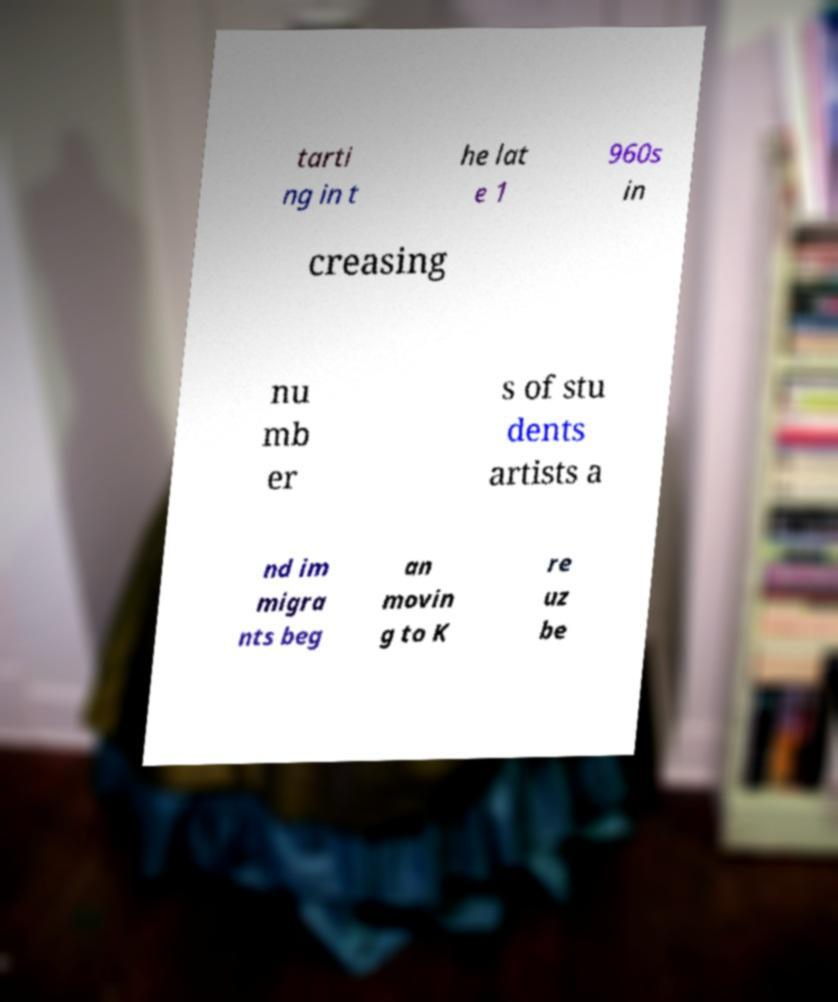Please identify and transcribe the text found in this image. tarti ng in t he lat e 1 960s in creasing nu mb er s of stu dents artists a nd im migra nts beg an movin g to K re uz be 